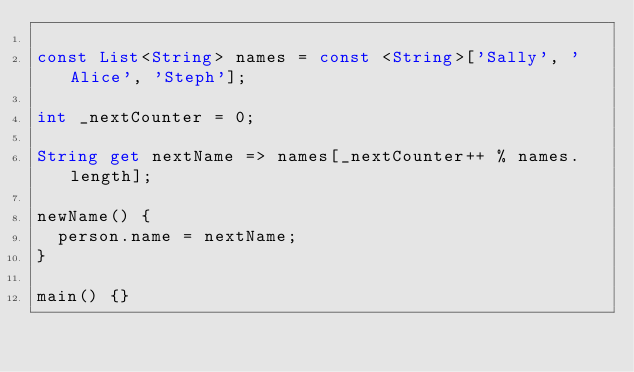<code> <loc_0><loc_0><loc_500><loc_500><_Dart_>
const List<String> names = const <String>['Sally', 'Alice', 'Steph'];

int _nextCounter = 0;

String get nextName => names[_nextCounter++ % names.length];

newName() {
  person.name = nextName;
}

main() {}</code> 